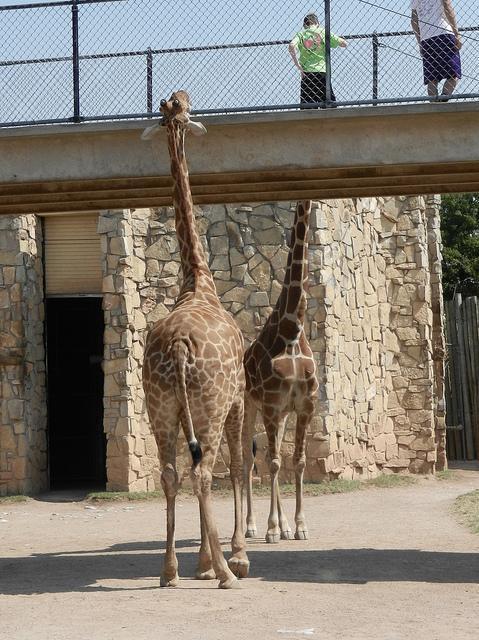How many people are visible?
Give a very brief answer. 2. How many giraffes are there?
Give a very brief answer. 2. 